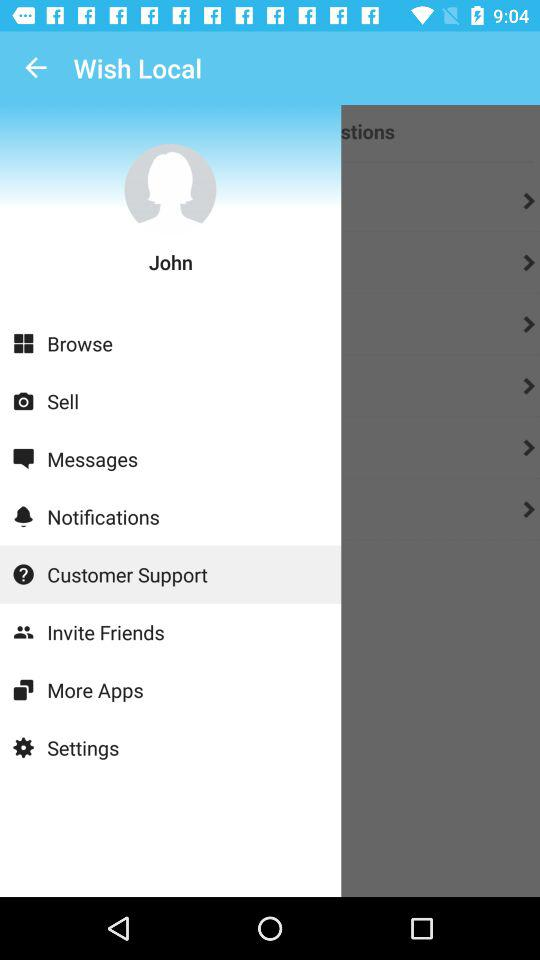Which items are up for sale?
When the provided information is insufficient, respond with <no answer>. <no answer> 